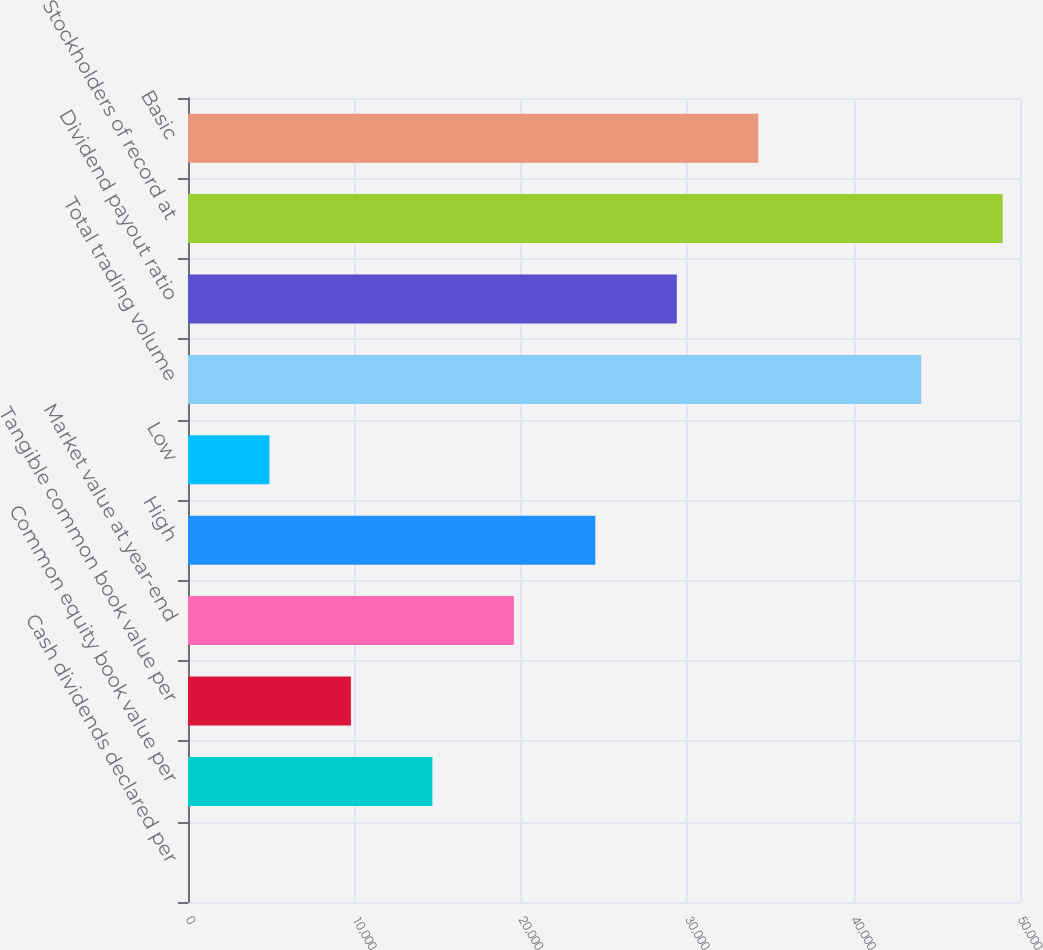Convert chart to OTSL. <chart><loc_0><loc_0><loc_500><loc_500><bar_chart><fcel>Cash dividends declared per<fcel>Common equity book value per<fcel>Tangible common book value per<fcel>Market value at year-end<fcel>High<fcel>Low<fcel>Total trading volume<fcel>Dividend payout ratio<fcel>Stockholders of record at<fcel>Basic<nl><fcel>0.26<fcel>14687.6<fcel>9791.8<fcel>19583.3<fcel>24479.1<fcel>4896.03<fcel>44062.2<fcel>29374.9<fcel>48958<fcel>34270.7<nl></chart> 